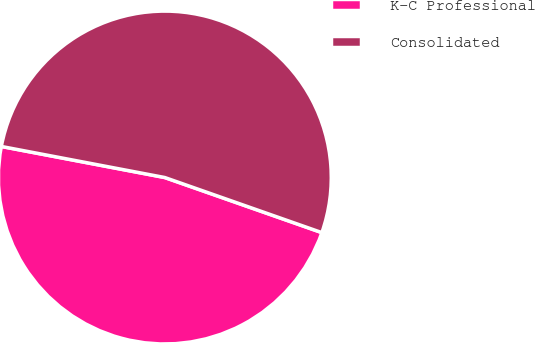Convert chart to OTSL. <chart><loc_0><loc_0><loc_500><loc_500><pie_chart><fcel>K-C Professional<fcel>Consolidated<nl><fcel>47.62%<fcel>52.38%<nl></chart> 